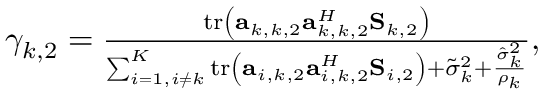Convert formula to latex. <formula><loc_0><loc_0><loc_500><loc_500>\begin{array} { r } { \gamma _ { k , 2 } = \frac { t r \left ( \mathbf a _ { k , k , 2 } \mathbf a _ { k , k , 2 } ^ { H } \mathbf S _ { k , 2 } \right ) } { \sum _ { i = 1 , i \neq k } ^ { K } t r \left ( \mathbf a _ { i , k , 2 } \mathbf a _ { i , k , 2 } ^ { H } \mathbf S _ { i , 2 } \right ) + \tilde { \sigma } _ { k } ^ { 2 } + \frac { \hat { \sigma } _ { k } ^ { 2 } } { \rho _ { k } } } , } \end{array}</formula> 